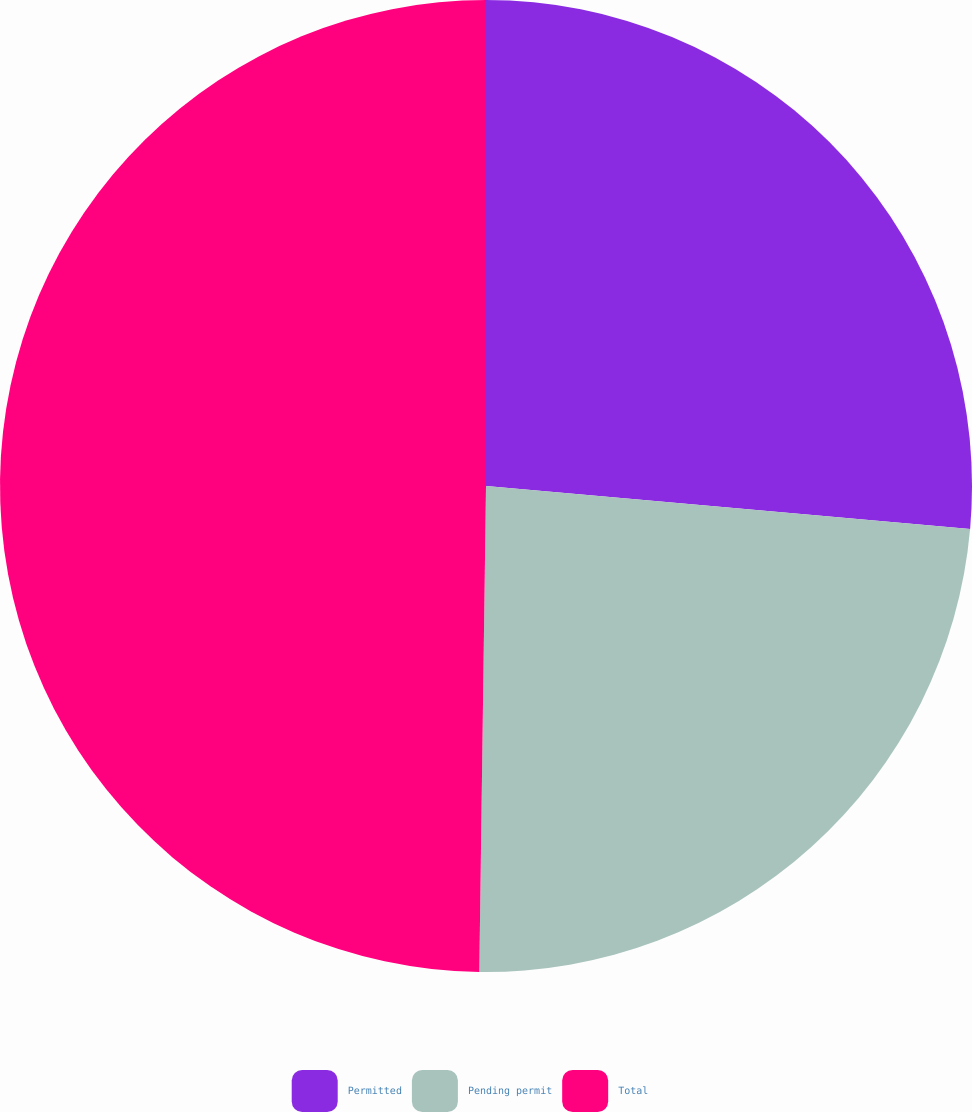Convert chart. <chart><loc_0><loc_0><loc_500><loc_500><pie_chart><fcel>Permitted<fcel>Pending permit<fcel>Total<nl><fcel>26.41%<fcel>23.81%<fcel>49.78%<nl></chart> 